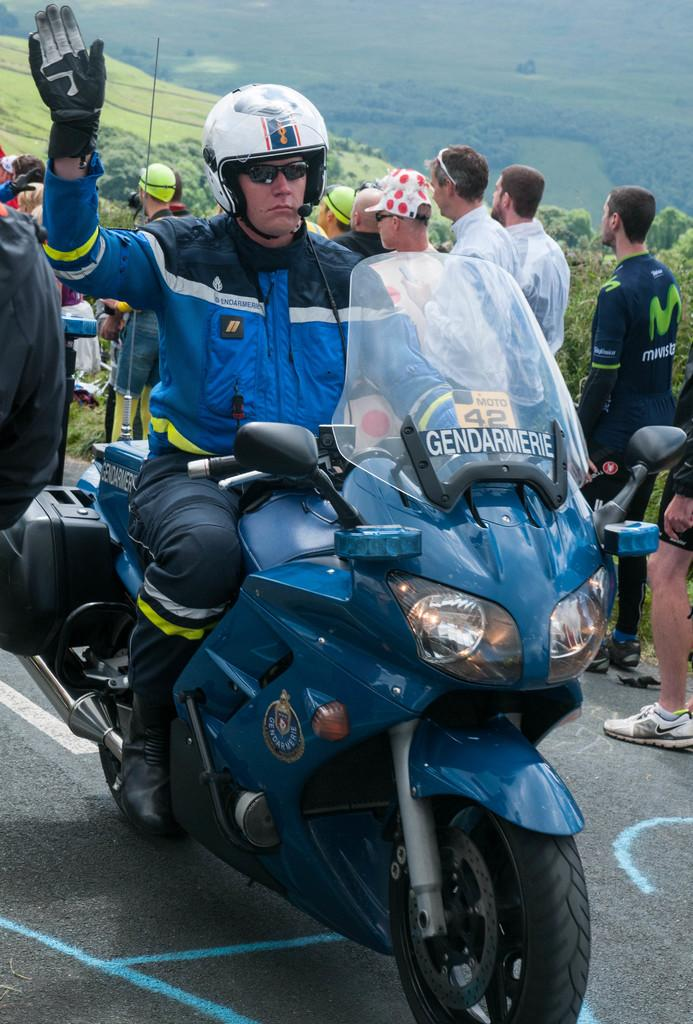What is the man in the image doing? The man is riding a motorcycle in the image. Are there any other people present in the image? Yes, there are people on the side of the motorcycle. What type of natural environment can be seen in the image? There are trees visible in the image. What type of scent can be smelled coming from the motorcycle in the image? There is no indication of any scent in the image, as smells cannot be captured in a photograph. What type of wall can be seen surrounding the motorcycle in the image? There is no wall surrounding the motorcycle in the image. What type of can is visible on the motorcycle in the image? There is no can visible on the motorcycle in the image. 